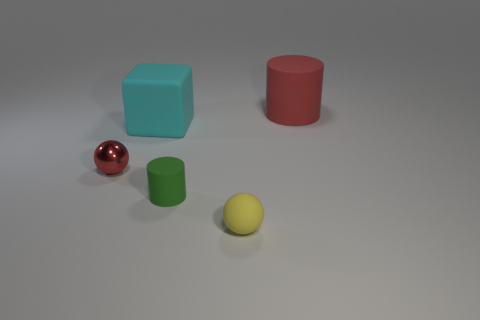Subtract 1 cubes. How many cubes are left? 0 Add 2 large matte blocks. How many objects exist? 7 Subtract all green cylinders. How many cylinders are left? 1 Subtract all gray cubes. Subtract all cyan cylinders. How many cubes are left? 1 Subtract all brown cylinders. How many brown cubes are left? 0 Subtract all red metallic spheres. Subtract all red things. How many objects are left? 2 Add 2 small yellow objects. How many small yellow objects are left? 3 Add 5 big purple cylinders. How many big purple cylinders exist? 5 Subtract 0 gray cylinders. How many objects are left? 5 Subtract all blocks. How many objects are left? 4 